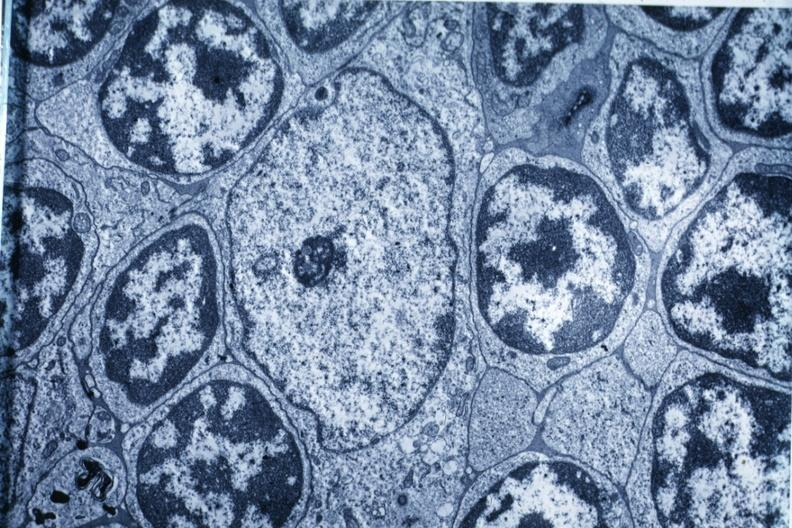what does this image show?
Answer the question using a single word or phrase. Electron micrograph 